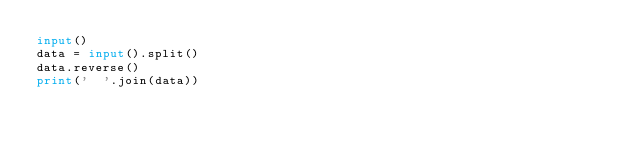Convert code to text. <code><loc_0><loc_0><loc_500><loc_500><_Python_>input()
data = input().split()
data.reverse()
print('  '.join(data))</code> 